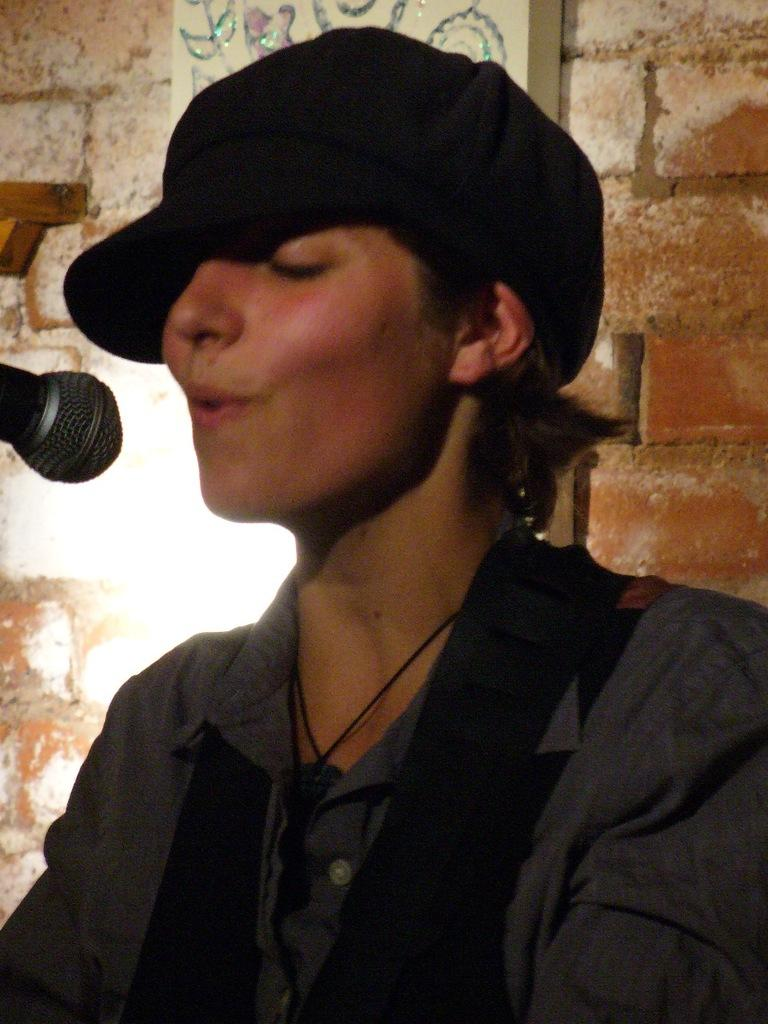What is the main subject of the image? There is a person in the image. What can be seen on the left side of the image? There is a mic on the left side of the image. What is present on the wall in the image? There is an object on the wall in the image. What is the person in the image wearing on their head? The person in the image is wearing a cap. What type of bean is cooking on the stove in the image? There is no stove or bean present in the image. 